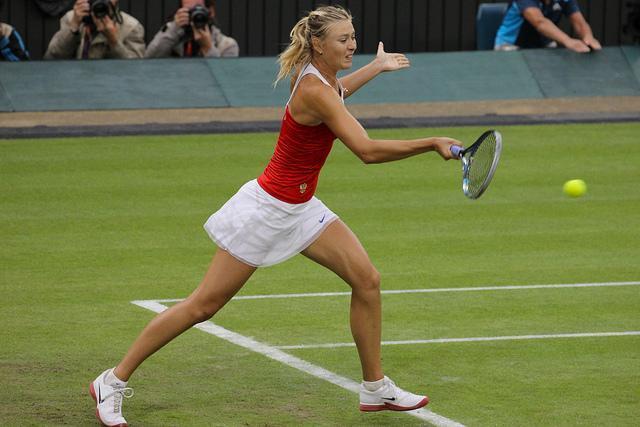How many camera's can you see?
Give a very brief answer. 2. How many people are in the picture?
Give a very brief answer. 4. How many bananas are there?
Give a very brief answer. 0. 